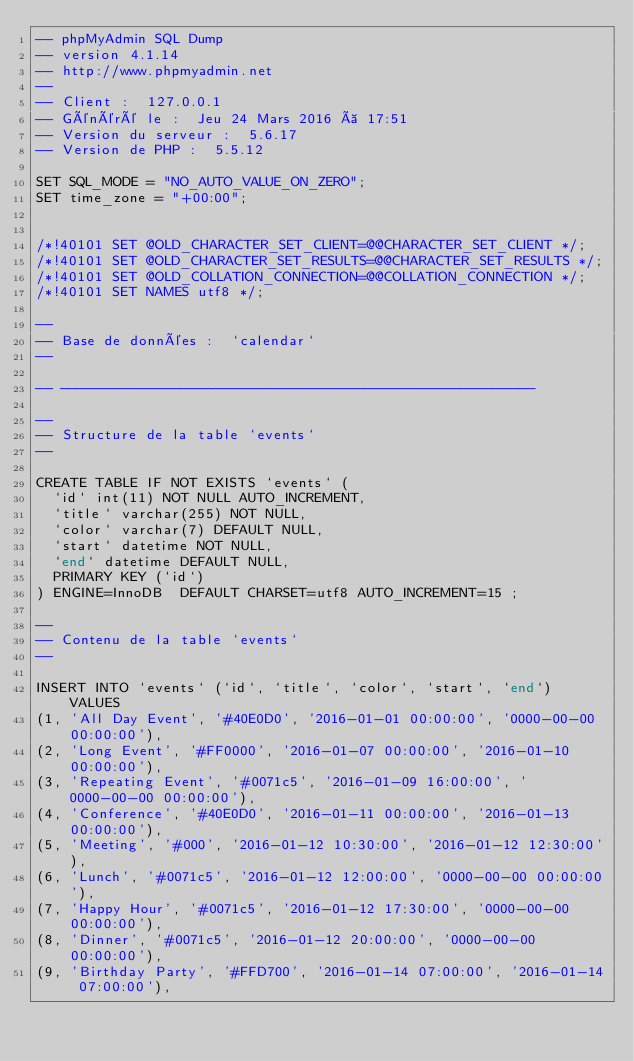<code> <loc_0><loc_0><loc_500><loc_500><_SQL_>-- phpMyAdmin SQL Dump
-- version 4.1.14
-- http://www.phpmyadmin.net
--
-- Client :  127.0.0.1
-- Généré le :  Jeu 24 Mars 2016 à 17:51
-- Version du serveur :  5.6.17
-- Version de PHP :  5.5.12

SET SQL_MODE = "NO_AUTO_VALUE_ON_ZERO";
SET time_zone = "+00:00";


/*!40101 SET @OLD_CHARACTER_SET_CLIENT=@@CHARACTER_SET_CLIENT */;
/*!40101 SET @OLD_CHARACTER_SET_RESULTS=@@CHARACTER_SET_RESULTS */;
/*!40101 SET @OLD_COLLATION_CONNECTION=@@COLLATION_CONNECTION */;
/*!40101 SET NAMES utf8 */;

--
-- Base de données :  `calendar`
--

-- --------------------------------------------------------

--
-- Structure de la table `events`
--

CREATE TABLE IF NOT EXISTS `events` (
  `id` int(11) NOT NULL AUTO_INCREMENT,
  `title` varchar(255) NOT NULL,
  `color` varchar(7) DEFAULT NULL,
  `start` datetime NOT NULL,
  `end` datetime DEFAULT NULL,
  PRIMARY KEY (`id`)
) ENGINE=InnoDB  DEFAULT CHARSET=utf8 AUTO_INCREMENT=15 ;

--
-- Contenu de la table `events`
--

INSERT INTO `events` (`id`, `title`, `color`, `start`, `end`) VALUES
(1, 'All Day Event', '#40E0D0', '2016-01-01 00:00:00', '0000-00-00 00:00:00'),
(2, 'Long Event', '#FF0000', '2016-01-07 00:00:00', '2016-01-10 00:00:00'),
(3, 'Repeating Event', '#0071c5', '2016-01-09 16:00:00', '0000-00-00 00:00:00'),
(4, 'Conference', '#40E0D0', '2016-01-11 00:00:00', '2016-01-13 00:00:00'),
(5, 'Meeting', '#000', '2016-01-12 10:30:00', '2016-01-12 12:30:00'),
(6, 'Lunch', '#0071c5', '2016-01-12 12:00:00', '0000-00-00 00:00:00'),
(7, 'Happy Hour', '#0071c5', '2016-01-12 17:30:00', '0000-00-00 00:00:00'),
(8, 'Dinner', '#0071c5', '2016-01-12 20:00:00', '0000-00-00 00:00:00'),
(9, 'Birthday Party', '#FFD700', '2016-01-14 07:00:00', '2016-01-14 07:00:00'),</code> 